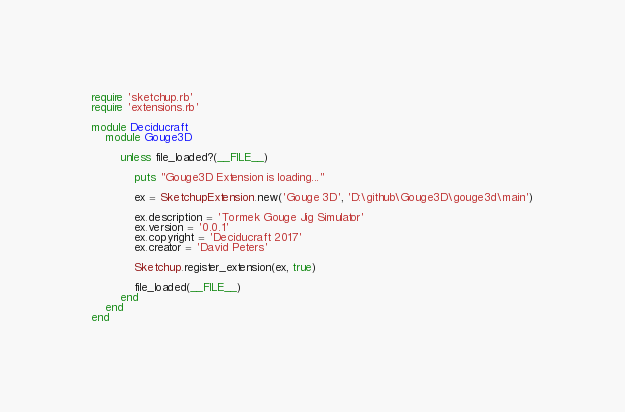<code> <loc_0><loc_0><loc_500><loc_500><_Ruby_>require 'sketchup.rb'
require 'extensions.rb'

module Deciducraft
    module Gouge3D

        unless file_loaded?(__FILE__)

            puts "Gouge3D Extension is loading..."

            ex = SketchupExtension.new('Gouge 3D', 'D:\github\Gouge3D\gouge3d\main')

            ex.description = 'Tormek Gouge Jig Simulator'
            ex.version = '0.0.1'
            ex.copyright = 'Deciducraft 2017'
            ex.creator = 'David Peters'

            Sketchup.register_extension(ex, true)

            file_loaded(__FILE__)
        end
    end
end
</code> 